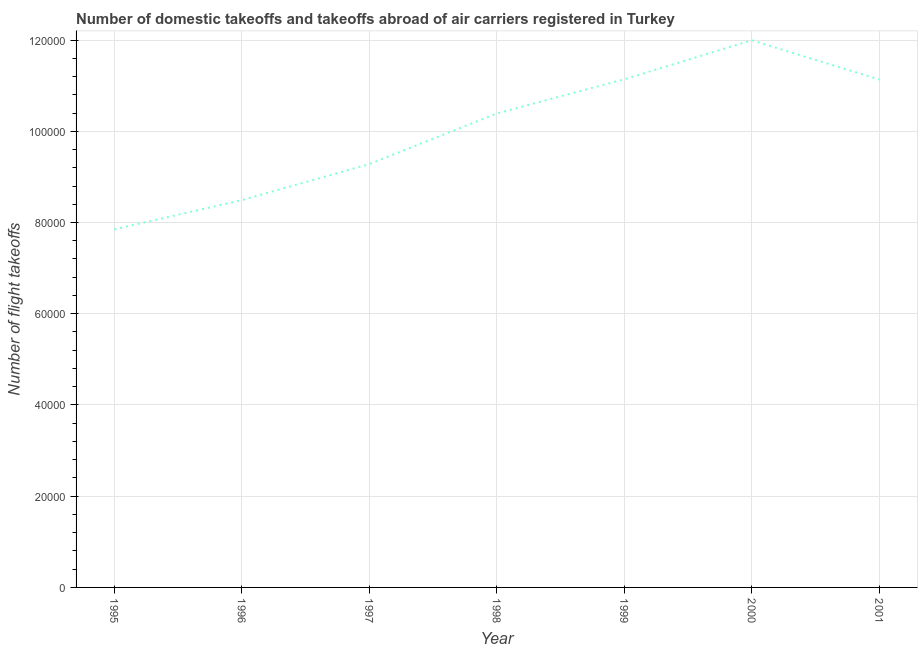What is the number of flight takeoffs in 1999?
Your answer should be compact. 1.11e+05. Across all years, what is the maximum number of flight takeoffs?
Keep it short and to the point. 1.20e+05. Across all years, what is the minimum number of flight takeoffs?
Offer a terse response. 7.85e+04. What is the sum of the number of flight takeoffs?
Your response must be concise. 7.03e+05. What is the difference between the number of flight takeoffs in 1995 and 2000?
Your answer should be very brief. -4.14e+04. What is the average number of flight takeoffs per year?
Provide a succinct answer. 1.00e+05. What is the median number of flight takeoffs?
Keep it short and to the point. 1.04e+05. What is the ratio of the number of flight takeoffs in 1998 to that in 2000?
Your answer should be compact. 0.87. Is the number of flight takeoffs in 1996 less than that in 2001?
Provide a short and direct response. Yes. What is the difference between the highest and the second highest number of flight takeoffs?
Provide a short and direct response. 8545. Is the sum of the number of flight takeoffs in 1995 and 1998 greater than the maximum number of flight takeoffs across all years?
Offer a very short reply. Yes. What is the difference between the highest and the lowest number of flight takeoffs?
Offer a terse response. 4.14e+04. What is the difference between two consecutive major ticks on the Y-axis?
Your response must be concise. 2.00e+04. Are the values on the major ticks of Y-axis written in scientific E-notation?
Offer a terse response. No. What is the title of the graph?
Provide a succinct answer. Number of domestic takeoffs and takeoffs abroad of air carriers registered in Turkey. What is the label or title of the X-axis?
Make the answer very short. Year. What is the label or title of the Y-axis?
Your response must be concise. Number of flight takeoffs. What is the Number of flight takeoffs in 1995?
Keep it short and to the point. 7.85e+04. What is the Number of flight takeoffs of 1996?
Provide a succinct answer. 8.49e+04. What is the Number of flight takeoffs in 1997?
Your response must be concise. 9.28e+04. What is the Number of flight takeoffs of 1998?
Offer a very short reply. 1.04e+05. What is the Number of flight takeoffs of 1999?
Make the answer very short. 1.11e+05. What is the Number of flight takeoffs of 2000?
Ensure brevity in your answer.  1.20e+05. What is the Number of flight takeoffs of 2001?
Your answer should be very brief. 1.11e+05. What is the difference between the Number of flight takeoffs in 1995 and 1996?
Offer a very short reply. -6400. What is the difference between the Number of flight takeoffs in 1995 and 1997?
Make the answer very short. -1.43e+04. What is the difference between the Number of flight takeoffs in 1995 and 1998?
Keep it short and to the point. -2.54e+04. What is the difference between the Number of flight takeoffs in 1995 and 1999?
Your answer should be very brief. -3.29e+04. What is the difference between the Number of flight takeoffs in 1995 and 2000?
Provide a succinct answer. -4.14e+04. What is the difference between the Number of flight takeoffs in 1995 and 2001?
Keep it short and to the point. -3.28e+04. What is the difference between the Number of flight takeoffs in 1996 and 1997?
Ensure brevity in your answer.  -7900. What is the difference between the Number of flight takeoffs in 1996 and 1998?
Offer a terse response. -1.90e+04. What is the difference between the Number of flight takeoffs in 1996 and 1999?
Provide a short and direct response. -2.65e+04. What is the difference between the Number of flight takeoffs in 1996 and 2000?
Provide a succinct answer. -3.50e+04. What is the difference between the Number of flight takeoffs in 1996 and 2001?
Make the answer very short. -2.64e+04. What is the difference between the Number of flight takeoffs in 1997 and 1998?
Provide a short and direct response. -1.11e+04. What is the difference between the Number of flight takeoffs in 1997 and 1999?
Offer a very short reply. -1.86e+04. What is the difference between the Number of flight takeoffs in 1997 and 2000?
Your response must be concise. -2.71e+04. What is the difference between the Number of flight takeoffs in 1997 and 2001?
Your answer should be very brief. -1.85e+04. What is the difference between the Number of flight takeoffs in 1998 and 1999?
Offer a terse response. -7500. What is the difference between the Number of flight takeoffs in 1998 and 2000?
Keep it short and to the point. -1.60e+04. What is the difference between the Number of flight takeoffs in 1998 and 2001?
Your response must be concise. -7442. What is the difference between the Number of flight takeoffs in 1999 and 2000?
Give a very brief answer. -8545. What is the difference between the Number of flight takeoffs in 2000 and 2001?
Your answer should be compact. 8603. What is the ratio of the Number of flight takeoffs in 1995 to that in 1996?
Offer a terse response. 0.93. What is the ratio of the Number of flight takeoffs in 1995 to that in 1997?
Provide a succinct answer. 0.85. What is the ratio of the Number of flight takeoffs in 1995 to that in 1998?
Make the answer very short. 0.76. What is the ratio of the Number of flight takeoffs in 1995 to that in 1999?
Provide a short and direct response. 0.7. What is the ratio of the Number of flight takeoffs in 1995 to that in 2000?
Provide a short and direct response. 0.65. What is the ratio of the Number of flight takeoffs in 1995 to that in 2001?
Give a very brief answer. 0.7. What is the ratio of the Number of flight takeoffs in 1996 to that in 1997?
Offer a very short reply. 0.92. What is the ratio of the Number of flight takeoffs in 1996 to that in 1998?
Offer a very short reply. 0.82. What is the ratio of the Number of flight takeoffs in 1996 to that in 1999?
Provide a short and direct response. 0.76. What is the ratio of the Number of flight takeoffs in 1996 to that in 2000?
Provide a succinct answer. 0.71. What is the ratio of the Number of flight takeoffs in 1996 to that in 2001?
Offer a very short reply. 0.76. What is the ratio of the Number of flight takeoffs in 1997 to that in 1998?
Give a very brief answer. 0.89. What is the ratio of the Number of flight takeoffs in 1997 to that in 1999?
Ensure brevity in your answer.  0.83. What is the ratio of the Number of flight takeoffs in 1997 to that in 2000?
Provide a short and direct response. 0.77. What is the ratio of the Number of flight takeoffs in 1997 to that in 2001?
Offer a very short reply. 0.83. What is the ratio of the Number of flight takeoffs in 1998 to that in 1999?
Provide a short and direct response. 0.93. What is the ratio of the Number of flight takeoffs in 1998 to that in 2000?
Provide a succinct answer. 0.87. What is the ratio of the Number of flight takeoffs in 1998 to that in 2001?
Offer a very short reply. 0.93. What is the ratio of the Number of flight takeoffs in 1999 to that in 2000?
Provide a succinct answer. 0.93. What is the ratio of the Number of flight takeoffs in 2000 to that in 2001?
Your response must be concise. 1.08. 